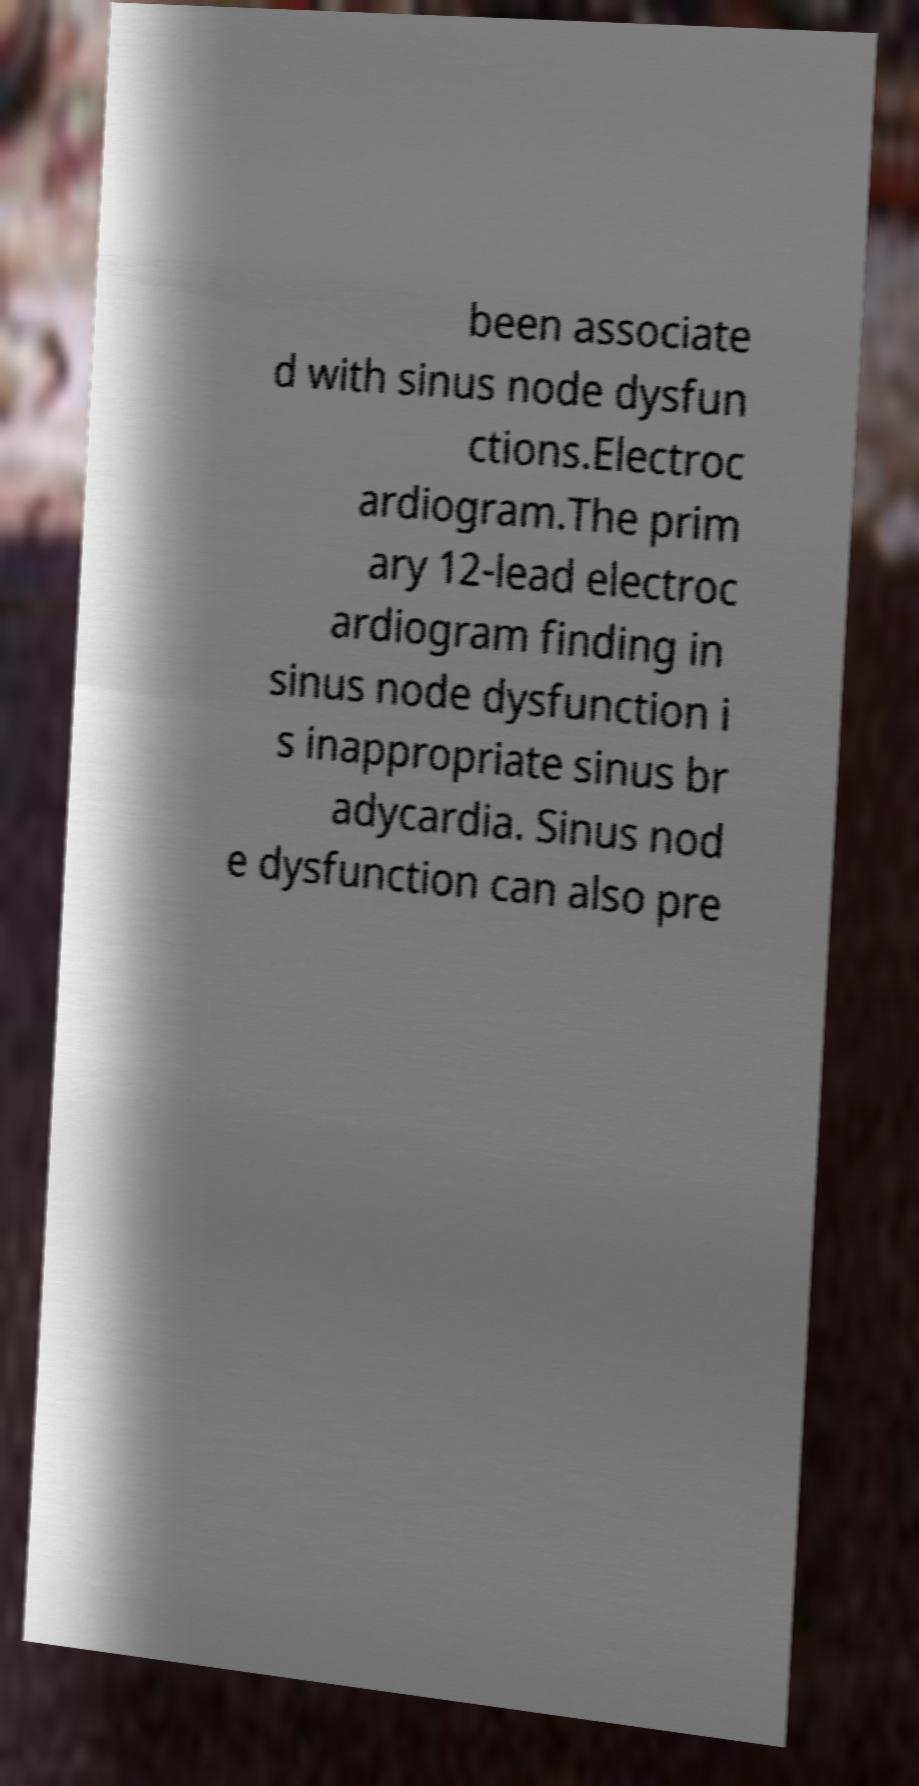Could you assist in decoding the text presented in this image and type it out clearly? been associate d with sinus node dysfun ctions.Electroc ardiogram.The prim ary 12-lead electroc ardiogram finding in sinus node dysfunction i s inappropriate sinus br adycardia. Sinus nod e dysfunction can also pre 